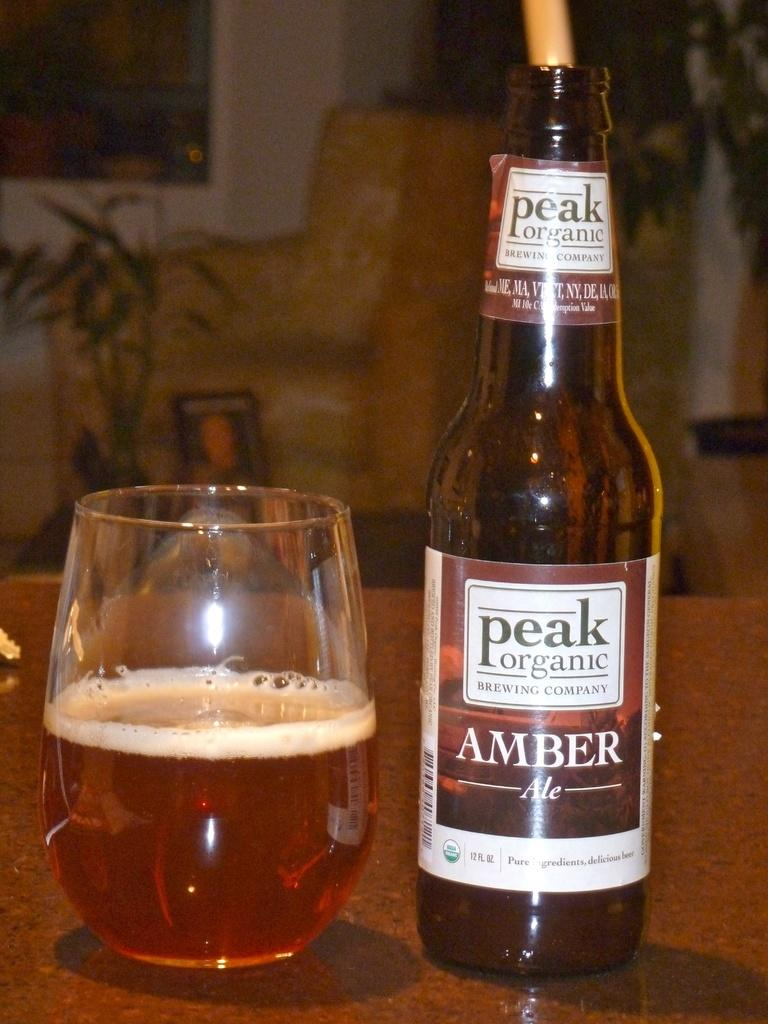<image>
Write a terse but informative summary of the picture. A bottle of Peak Organic Amber beer next to a glass. 